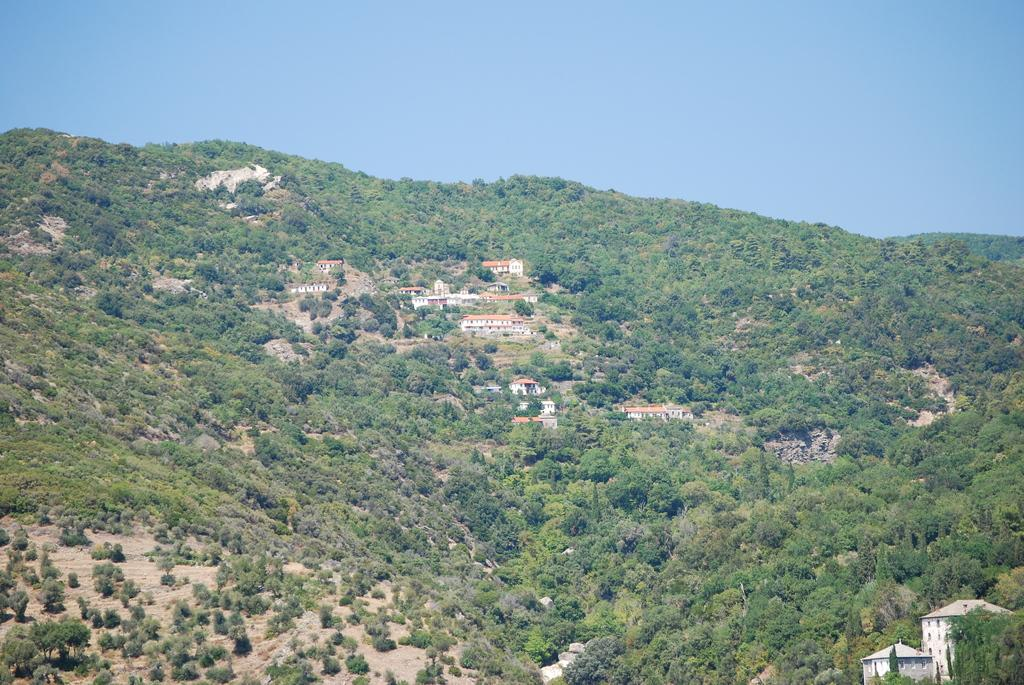What type of surface can be seen in the image? There is ground visible in the image. What type of natural elements are present in the image? There are trees in the image. What type of man-made structures are present in the image? There are buildings in the image. What colors are the buildings in the image? The buildings are white and orange in color. What is visible in the background of the image? The sky is visible in the background of the image. What type of knowledge does the mother possess in the image? There is no mother present in the image, so it is not possible to determine what type of knowledge she might possess. 